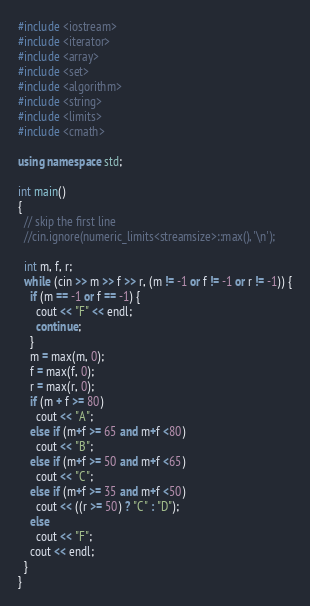<code> <loc_0><loc_0><loc_500><loc_500><_C++_>#include <iostream>
#include <iterator>
#include <array>
#include <set>
#include <algorithm>
#include <string>
#include <limits>
#include <cmath>

using namespace std;

int main()
{
  // skip the first line
  //cin.ignore(numeric_limits<streamsize>::max(), '\n');

  int m, f, r;
  while (cin >> m >> f >> r, (m != -1 or f != -1 or r != -1)) {
    if (m == -1 or f == -1) {
      cout << "F" << endl;
      continue;
    }
    m = max(m, 0);
    f = max(f, 0);
    r = max(r, 0);
    if (m + f >= 80)
      cout << "A";
    else if (m+f >= 65 and m+f <80)
      cout << "B";
    else if (m+f >= 50 and m+f <65)
      cout << "C";
    else if (m+f >= 35 and m+f <50)
      cout << ((r >= 50) ? "C" : "D");
    else
      cout << "F";
    cout << endl;
  }
}

</code> 